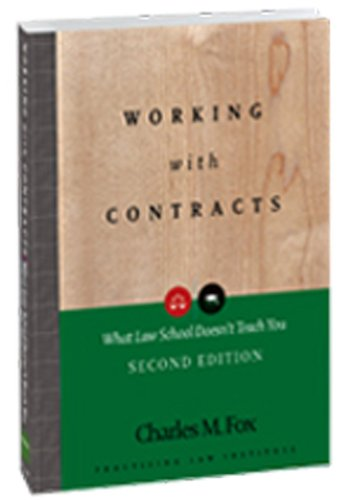Is this book related to Comics & Graphic Novels? No, this book is not related to Comics & Graphic Novels. It is an educational resource on contract law, targeting those in the legal profession or students of law. 